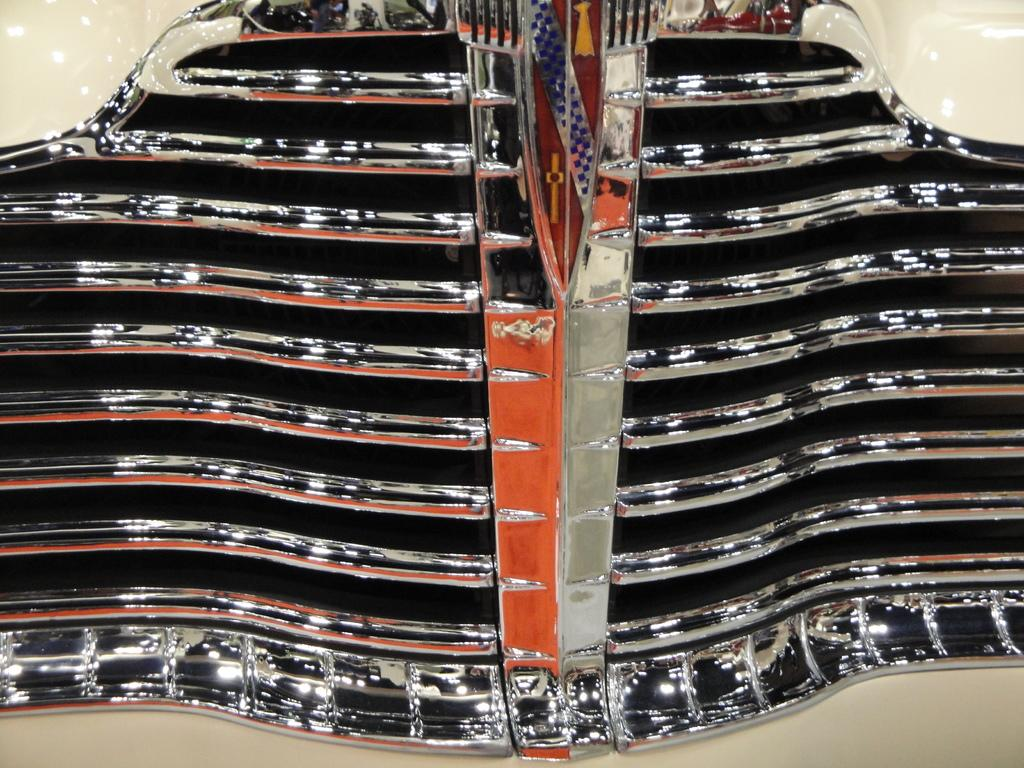What is the main subject of the image? The main subject of the image is a picture of a vehicle. What feature can be seen on the vehicle's bumper? The vehicle has grills on its bumper. Where is the playground located in the image? There is no playground present in the image; it only features a picture of a vehicle with grills on its bumper. Can you tell me how the grandmother is interacting with the vehicle in the image? There is no grandmother present in the image; it only features a picture of a vehicle with grills on its bumper. 